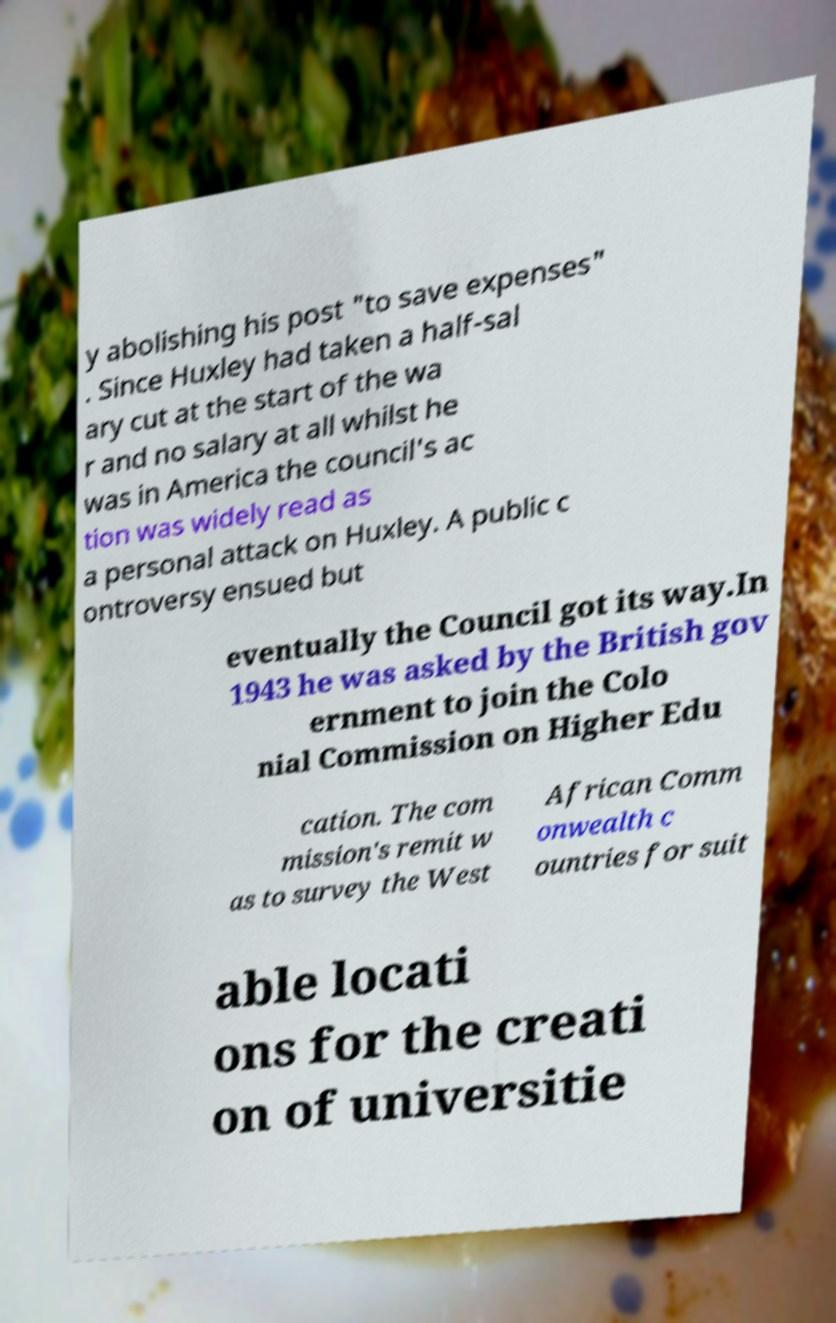There's text embedded in this image that I need extracted. Can you transcribe it verbatim? y abolishing his post "to save expenses" . Since Huxley had taken a half-sal ary cut at the start of the wa r and no salary at all whilst he was in America the council's ac tion was widely read as a personal attack on Huxley. A public c ontroversy ensued but eventually the Council got its way.In 1943 he was asked by the British gov ernment to join the Colo nial Commission on Higher Edu cation. The com mission's remit w as to survey the West African Comm onwealth c ountries for suit able locati ons for the creati on of universitie 